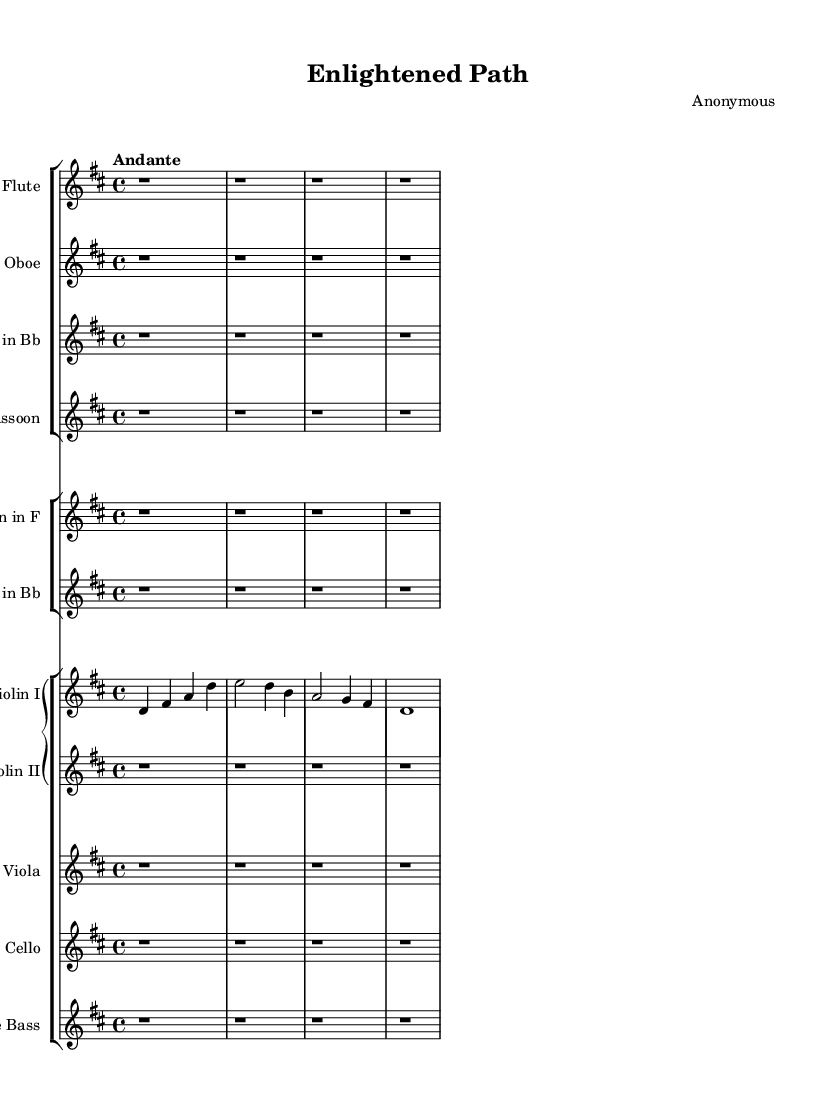What is the key signature of this music? The key signature is indicated at the beginning of the staff. There are two sharps, which correspond to F sharp and C sharp.
Answer: D major What is the time signature of this music? The time signature appears at the beginning of the staff next to the key signature. It is written as a fraction, with a 4 on top and a 4 on the bottom, indicating four beats per measure.
Answer: 4/4 What is the tempo marking of this music? The tempo marking is presented as a word above the staff. In this case, it states "Andante," which suggests a moderately slow pace.
Answer: Andante How many measures are in the main theme for Violin I? To find the number of measures in the main theme for Violin I, we count the number of bar lines in the corresponding staff line. By counting, we determine there are four measures represented by four bar lines.
Answer: 4 What instruments are present in this orchestral work? The instruments are specified in each staff section at the beginning of the score. By reviewing the labels, we can identify Flute, Oboe, Clarinet in B flat, Bassoon, Horn in F, Trumpet in B flat, Violin I, Violin II, Viola, Cello, and Double Bass.
Answer: Flute, Oboe, Clarinet in B flat, Bassoon, Horn in F, Trumpet in B flat, Violin I, Violin II, Viola, Cello, Double Bass What is the primary decorative element found in the melodic line of the main theme? The primary decorative element in the melodic line can be identified by looking for any embellishments or additional notes. In the main theme for Violin I, there are longer notes, which indicate a sustained melodic contour.
Answer: Sustained notes 